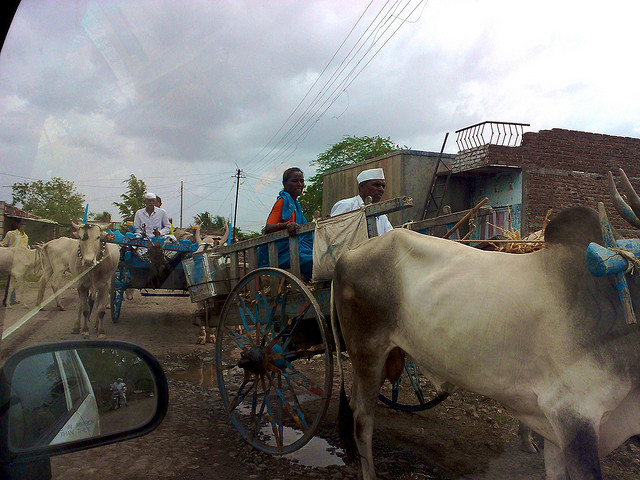<image>What kind of animal are they riding? I am not sure what kind of animal they are riding. It could be an ox, horse, cow, yak or even a moose. Where are the animals walking? I don't know where the animals are walking. It could be a road, street, or village. What kind of animal are they riding? It is ambiguous what kind of animal they are riding. It can be seen as oxen, ox, horse, cow, or yak. Where are the animals walking? I don't know where the animals are walking. It can be in the village, dirt road, street, or to the market. 